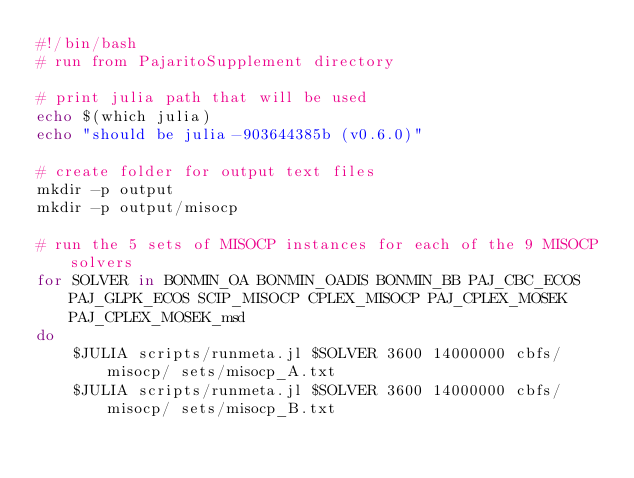Convert code to text. <code><loc_0><loc_0><loc_500><loc_500><_Bash_>#!/bin/bash
# run from PajaritoSupplement directory

# print julia path that will be used
echo $(which julia)
echo "should be julia-903644385b (v0.6.0)"

# create folder for output text files
mkdir -p output
mkdir -p output/misocp

# run the 5 sets of MISOCP instances for each of the 9 MISOCP solvers
for SOLVER in BONMIN_OA BONMIN_OADIS BONMIN_BB PAJ_CBC_ECOS PAJ_GLPK_ECOS SCIP_MISOCP CPLEX_MISOCP PAJ_CPLEX_MOSEK PAJ_CPLEX_MOSEK_msd
do
    $JULIA scripts/runmeta.jl $SOLVER 3600 14000000 cbfs/misocp/ sets/misocp_A.txt
    $JULIA scripts/runmeta.jl $SOLVER 3600 14000000 cbfs/misocp/ sets/misocp_B.txt</code> 